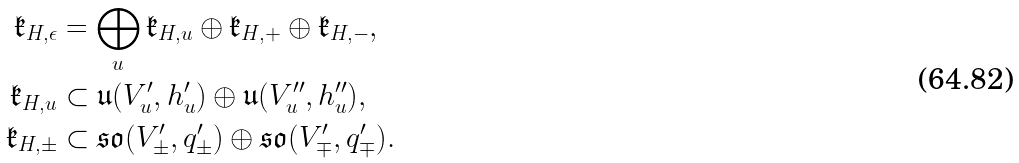<formula> <loc_0><loc_0><loc_500><loc_500>\mathfrak { k } _ { H , \epsilon } & = \bigoplus _ { u } \mathfrak { k } _ { H , u } \oplus \mathfrak { k } _ { H , + } \oplus \mathfrak { k } _ { H , - } , \\ \mathfrak { k } _ { H , u } & \subset \mathfrak { u } ( V ^ { \prime } _ { u } , h ^ { \prime } _ { u } ) \oplus \mathfrak { u } ( V ^ { \prime \prime } _ { u } , h ^ { \prime \prime } _ { u } ) , \\ \mathfrak { k } _ { H , \pm } & \subset \mathfrak { s o } ( V ^ { \prime } _ { \pm } , q ^ { \prime } _ { \pm } ) \oplus \mathfrak { s o } ( V ^ { \prime } _ { \mp } , q ^ { \prime } _ { \mp } ) .</formula> 